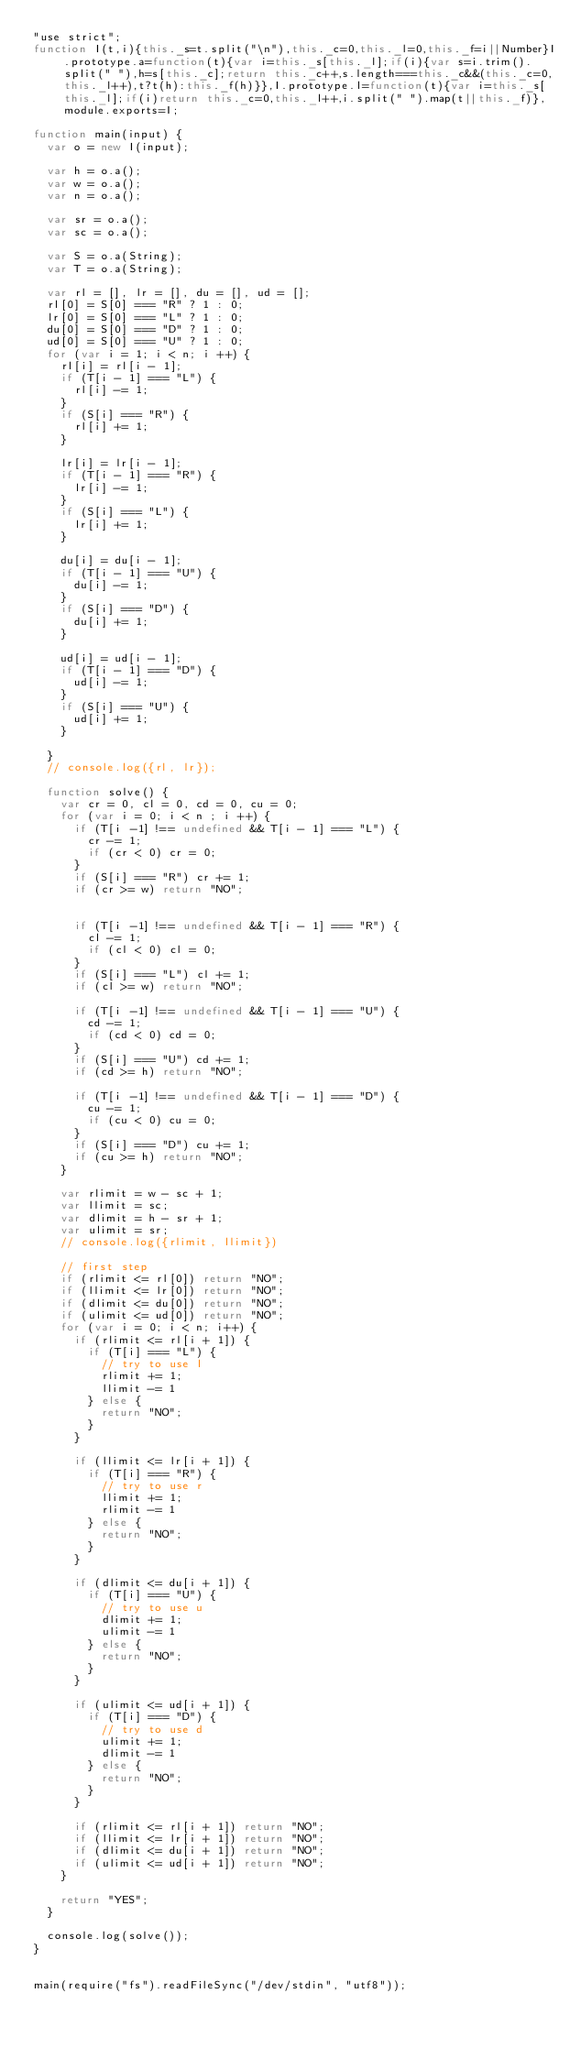<code> <loc_0><loc_0><loc_500><loc_500><_JavaScript_>"use strict";
function I(t,i){this._s=t.split("\n"),this._c=0,this._l=0,this._f=i||Number}I.prototype.a=function(t){var i=this._s[this._l];if(i){var s=i.trim().split(" "),h=s[this._c];return this._c++,s.length===this._c&&(this._c=0,this._l++),t?t(h):this._f(h)}},I.prototype.l=function(t){var i=this._s[this._l];if(i)return this._c=0,this._l++,i.split(" ").map(t||this._f)},module.exports=I;

function main(input) {
  var o = new I(input);

  var h = o.a();
  var w = o.a();
  var n = o.a();

  var sr = o.a();
  var sc = o.a();

  var S = o.a(String);
  var T = o.a(String);

  var rl = [], lr = [], du = [], ud = [];
  rl[0] = S[0] === "R" ? 1 : 0;
  lr[0] = S[0] === "L" ? 1 : 0;
  du[0] = S[0] === "D" ? 1 : 0;
  ud[0] = S[0] === "U" ? 1 : 0;
  for (var i = 1; i < n; i ++) {
    rl[i] = rl[i - 1];
    if (T[i - 1] === "L") {
      rl[i] -= 1;
    }
    if (S[i] === "R") {
      rl[i] += 1;
    }

    lr[i] = lr[i - 1];
    if (T[i - 1] === "R") {
      lr[i] -= 1;
    }
    if (S[i] === "L") {
      lr[i] += 1;
    }

    du[i] = du[i - 1];
    if (T[i - 1] === "U") {
      du[i] -= 1;
    }
    if (S[i] === "D") {
      du[i] += 1;
    }

    ud[i] = ud[i - 1];
    if (T[i - 1] === "D") {
      ud[i] -= 1;
    }
    if (S[i] === "U") {
      ud[i] += 1;
    }

  }
  // console.log({rl, lr});

  function solve() {
    var cr = 0, cl = 0, cd = 0, cu = 0;
    for (var i = 0; i < n ; i ++) {
      if (T[i -1] !== undefined && T[i - 1] === "L") {
        cr -= 1;
        if (cr < 0) cr = 0;
      }
      if (S[i] === "R") cr += 1;
      if (cr >= w) return "NO";

  
      if (T[i -1] !== undefined && T[i - 1] === "R") {
        cl -= 1;
        if (cl < 0) cl = 0;
      }
      if (S[i] === "L") cl += 1;
      if (cl >= w) return "NO";

      if (T[i -1] !== undefined && T[i - 1] === "U") {
        cd -= 1;
        if (cd < 0) cd = 0;
      }
      if (S[i] === "U") cd += 1;
      if (cd >= h) return "NO";

      if (T[i -1] !== undefined && T[i - 1] === "D") {
        cu -= 1;
        if (cu < 0) cu = 0;
      }
      if (S[i] === "D") cu += 1;
      if (cu >= h) return "NO";
    }

    var rlimit = w - sc + 1;
    var llimit = sc;
    var dlimit = h - sr + 1;
    var ulimit = sr;
    // console.log({rlimit, llimit})

    // first step
    if (rlimit <= rl[0]) return "NO";
    if (llimit <= lr[0]) return "NO";
    if (dlimit <= du[0]) return "NO";
    if (ulimit <= ud[0]) return "NO";
    for (var i = 0; i < n; i++) {
      if (rlimit <= rl[i + 1]) {
        if (T[i] === "L") {
          // try to use l
          rlimit += 1;
          llimit -= 1
        } else {
          return "NO";
        }
      }

      if (llimit <= lr[i + 1]) {
        if (T[i] === "R") {
          // try to use r
          llimit += 1;
          rlimit -= 1
        } else {
          return "NO";
        }
      }

      if (dlimit <= du[i + 1]) {
        if (T[i] === "U") {
          // try to use u
          dlimit += 1;
          ulimit -= 1
        } else {
          return "NO";
        }
      }

      if (ulimit <= ud[i + 1]) {
        if (T[i] === "D") {
          // try to use d
          ulimit += 1;
          dlimit -= 1
        } else {
          return "NO";
        }
      }

      if (rlimit <= rl[i + 1]) return "NO";
      if (llimit <= lr[i + 1]) return "NO";
      if (dlimit <= du[i + 1]) return "NO";
      if (ulimit <= ud[i + 1]) return "NO";
    }

    return "YES";
  }

  console.log(solve());
}


main(require("fs").readFileSync("/dev/stdin", "utf8"));
</code> 